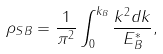<formula> <loc_0><loc_0><loc_500><loc_500>\rho _ { S B } = \frac { 1 } { \pi ^ { 2 } } \int _ { 0 } ^ { k _ { B } } \frac { k ^ { 2 } d k } { E ^ { * } _ { B } } ,</formula> 